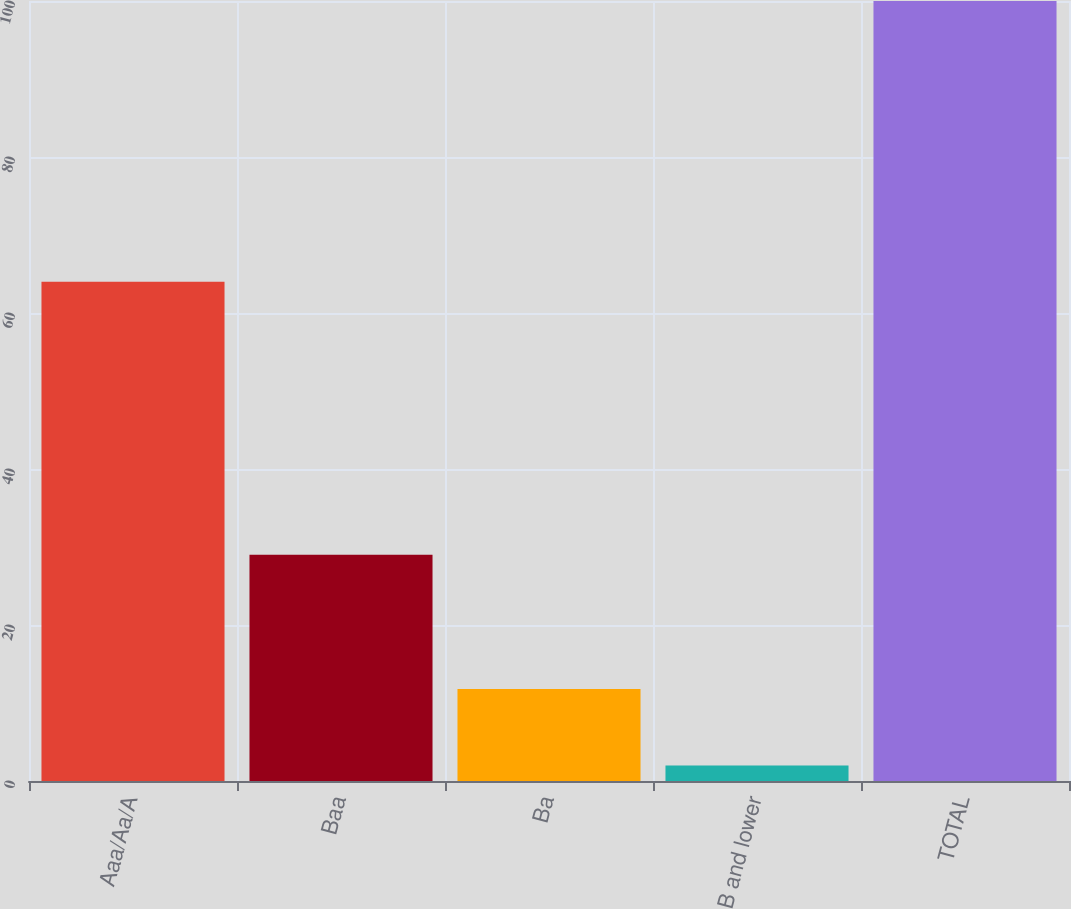Convert chart to OTSL. <chart><loc_0><loc_0><loc_500><loc_500><bar_chart><fcel>Aaa/Aa/A<fcel>Baa<fcel>Ba<fcel>B and lower<fcel>TOTAL<nl><fcel>64<fcel>29<fcel>11.8<fcel>2<fcel>100<nl></chart> 